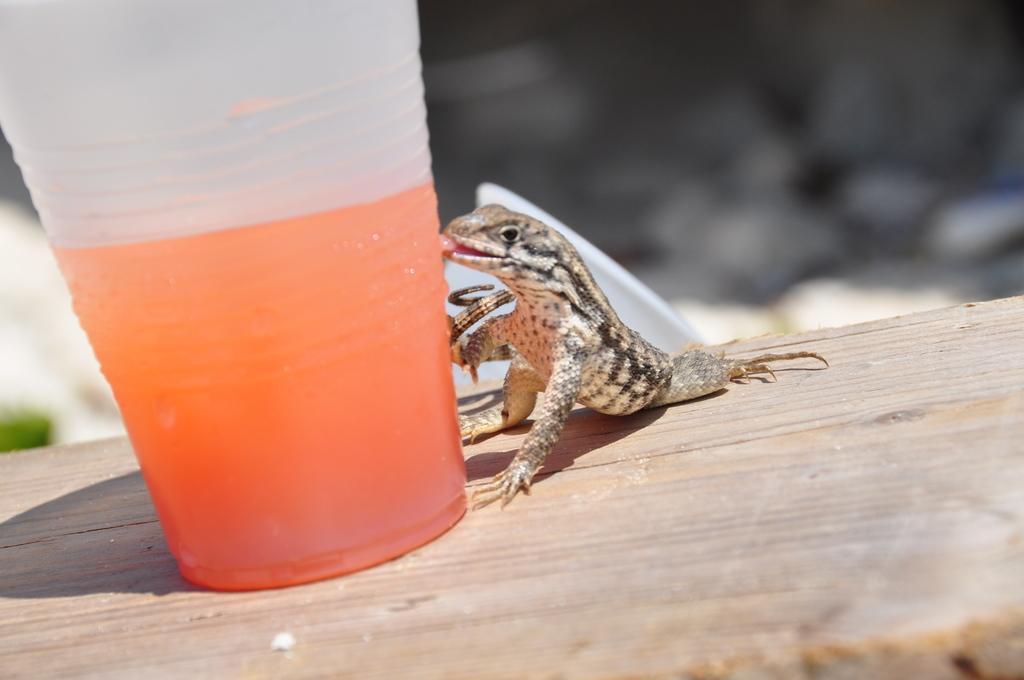Can you describe this image briefly? In this image I can see a lizard, a glass and in it I can see orange colour drink. I can also see this image is blurry from background. 